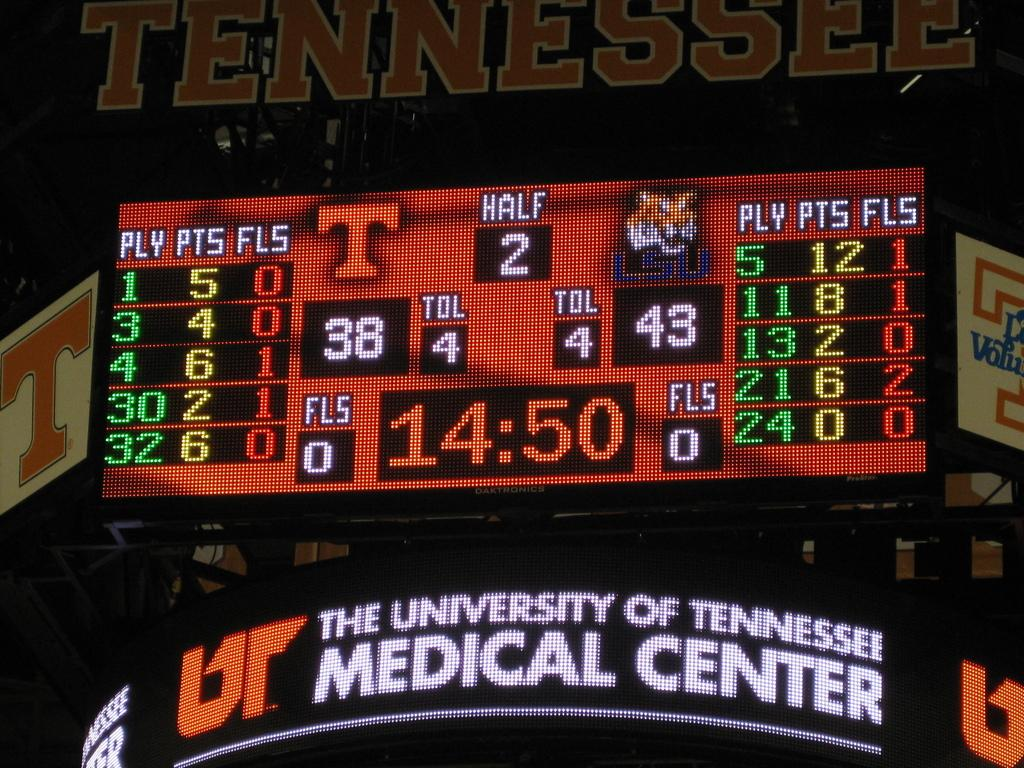<image>
Summarize the visual content of the image. A colorful board with the words University of Tennessee Medical center underneath. 